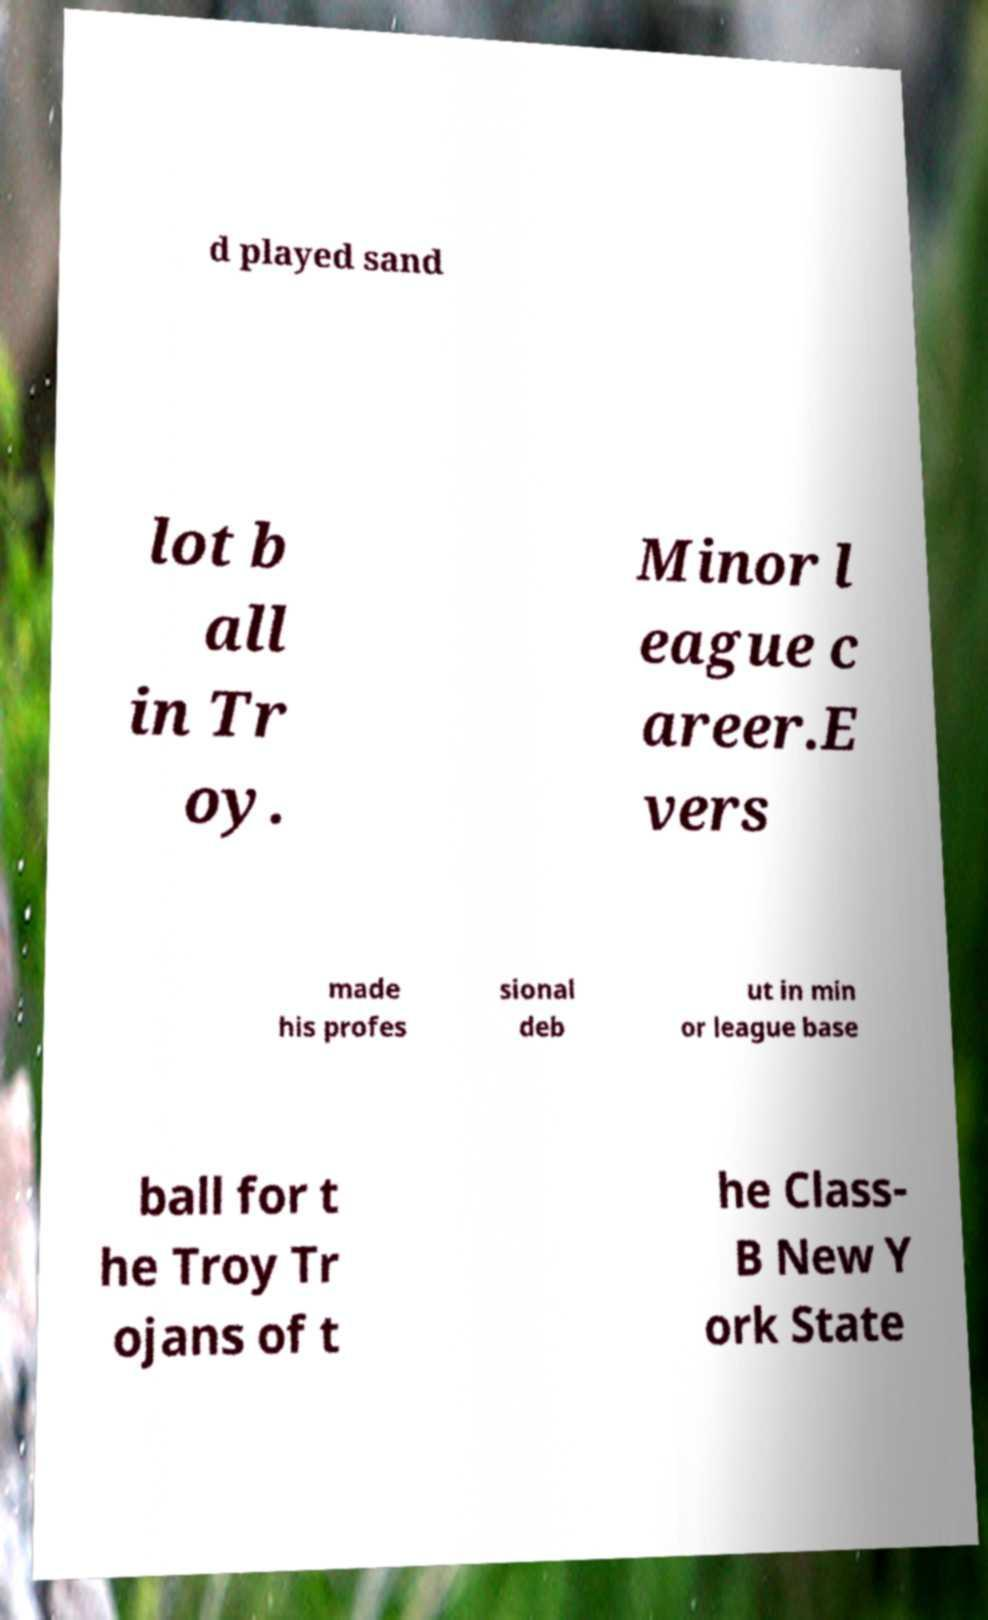Can you read and provide the text displayed in the image?This photo seems to have some interesting text. Can you extract and type it out for me? d played sand lot b all in Tr oy. Minor l eague c areer.E vers made his profes sional deb ut in min or league base ball for t he Troy Tr ojans of t he Class- B New Y ork State 